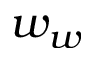Convert formula to latex. <formula><loc_0><loc_0><loc_500><loc_500>w _ { w }</formula> 